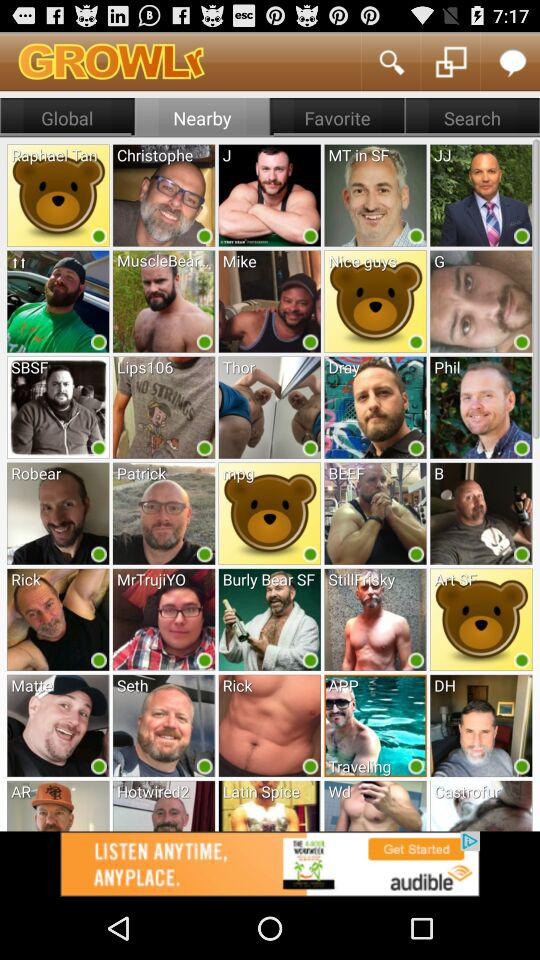Which tab is selected? The selected tab is "Nearby". 